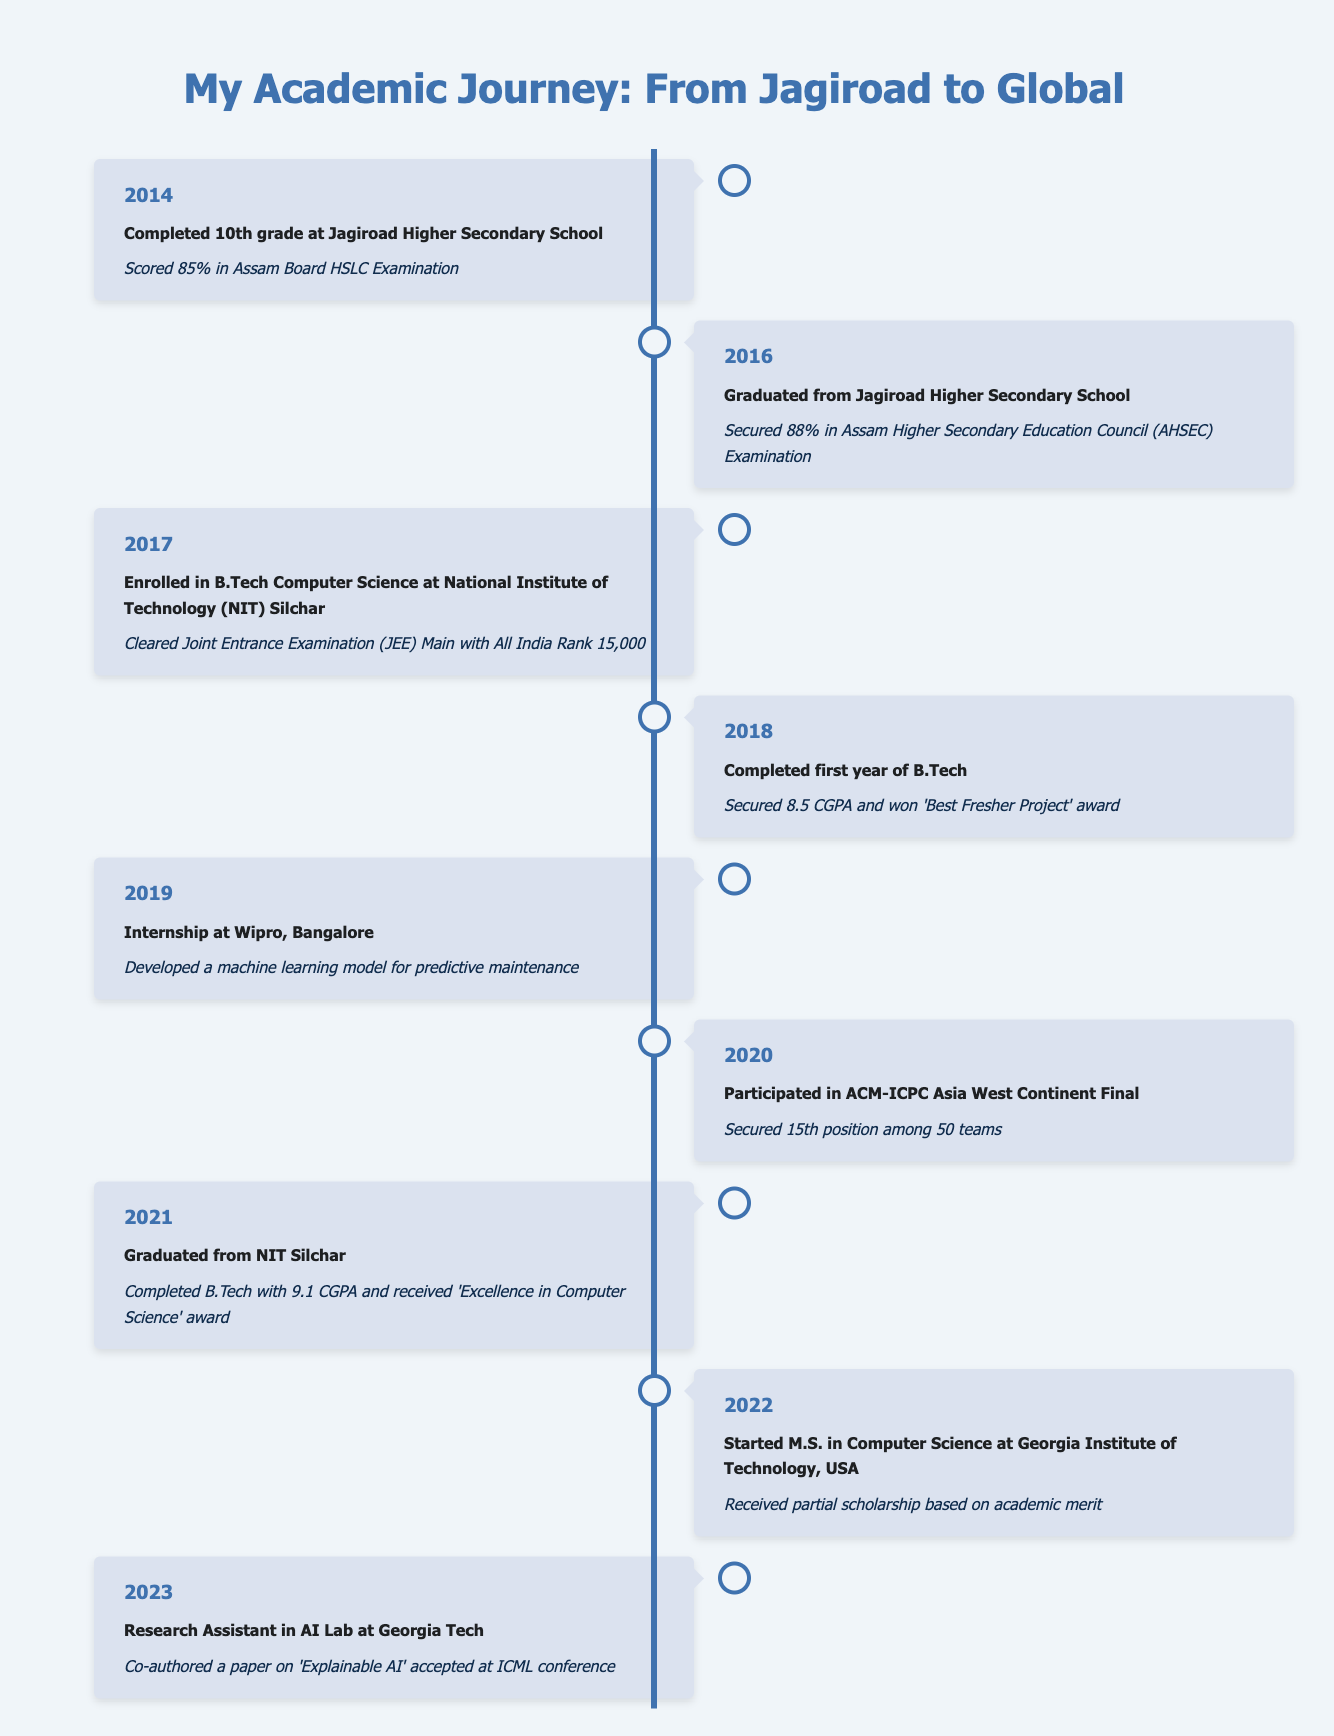What year did the individual complete their 10th grade? According to the table, the event of completing 10th grade is listed under the year 2014.
Answer: 2014 What was the percentage score in the Assam Board HSLC Examination? The achievement listed for the year 2014 states a score of 85% in the Assam Board HSLC Examination.
Answer: 85% Did the individual receive any awards during their B.Tech studies? The timeline mentions that the individual received the 'Excellence in Computer Science' award at graduation in 2021, as well as a 'Best Fresher Project' award in 2018.
Answer: Yes What was the highest CGPA achieved during the B.Tech program? The highest CGPA mentioned is 9.1, which was achieved upon graduation from NIT Silchar in 2021.
Answer: 9.1 How many years did the individual spend in undergraduate studies from high school graduation to B.Tech graduation? The individual graduated from high school in 2016 and completed B.Tech in 2021. Hence, the duration is 2021 - 2016 = 5 years.
Answer: 5 years In which year did the individual start their M.S. program? The individual started the M.S. in Computer Science at Georgia Institute of Technology in the year 2022.
Answer: 2022 What significant achievement took place in 2023? In 2023, the individual co-authored a paper on 'Explainable AI' that was accepted at an ICML conference while working as a Research Assistant.
Answer: Co-authored a paper on 'Explainable AI' How does the individual’s academic performance compare between high school and undergraduate studies? In high school, the individual scored 88% upon graduation (2016) and had a CGPA of 9.1 during B.Tech (2021), showing a significant increase in academic performance.
Answer: Increased performance Did the individual participate in any competitions during their studies? Yes, the timeline shows that the individual participated in the ACM-ICPC Asia West Continent Final in 2020.
Answer: Yes What award did the individual earn during their first year of B.Tech? The individual won the 'Best Fresher Project' award in 2018 during their first year of B.Tech.
Answer: 'Best Fresher Project' award 